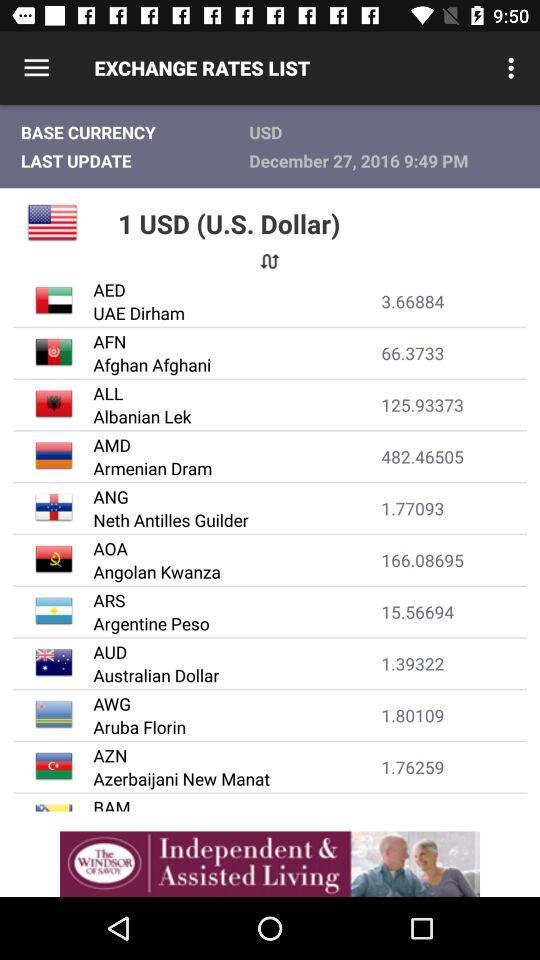What is the currency of the UAE? The currency of the UAE is the UAE dirham. 